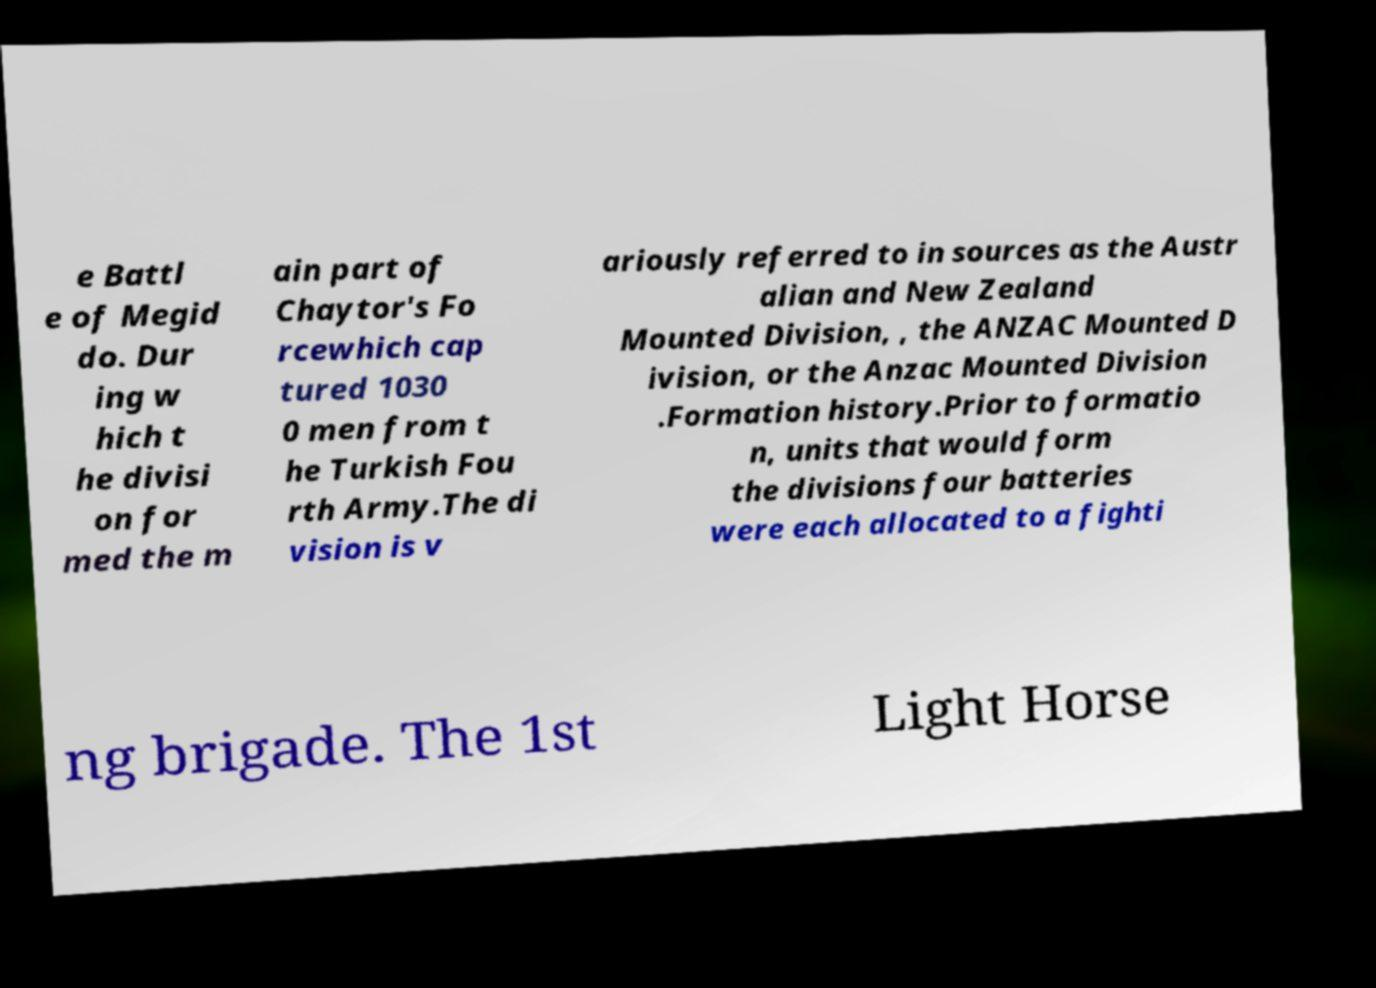Could you extract and type out the text from this image? e Battl e of Megid do. Dur ing w hich t he divisi on for med the m ain part of Chaytor's Fo rcewhich cap tured 1030 0 men from t he Turkish Fou rth Army.The di vision is v ariously referred to in sources as the Austr alian and New Zealand Mounted Division, , the ANZAC Mounted D ivision, or the Anzac Mounted Division .Formation history.Prior to formatio n, units that would form the divisions four batteries were each allocated to a fighti ng brigade. The 1st Light Horse 